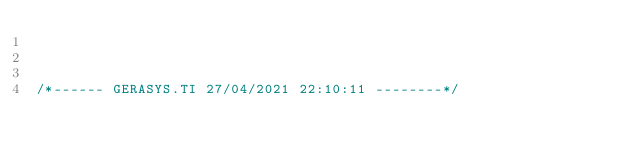Convert code to text. <code><loc_0><loc_0><loc_500><loc_500><_SQL_>


/*------ GERASYS.TI 27/04/2021 22:10:11 --------*/
</code> 